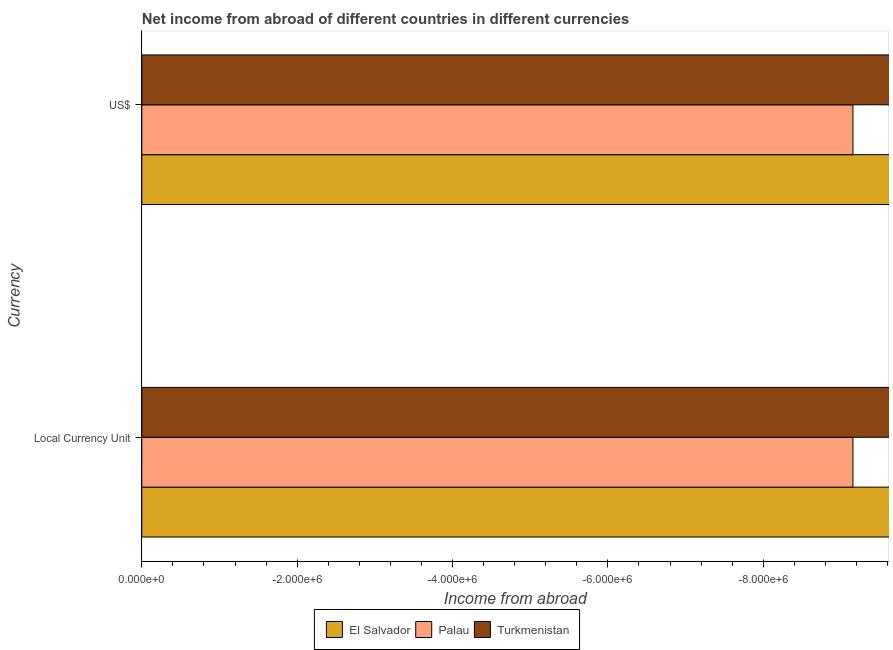Are the number of bars on each tick of the Y-axis equal?
Give a very brief answer. Yes. How many bars are there on the 2nd tick from the top?
Your answer should be compact. 0. How many bars are there on the 1st tick from the bottom?
Ensure brevity in your answer.  0. What is the label of the 1st group of bars from the top?
Ensure brevity in your answer.  US$. What is the income from abroad in us$ in Palau?
Your answer should be very brief. 0. What is the total income from abroad in us$ in the graph?
Make the answer very short. 0. In how many countries, is the income from abroad in us$ greater than -4400000 units?
Make the answer very short. 0. Are all the bars in the graph horizontal?
Give a very brief answer. Yes. What is the difference between two consecutive major ticks on the X-axis?
Provide a succinct answer. 2.00e+06. Are the values on the major ticks of X-axis written in scientific E-notation?
Your answer should be very brief. Yes. Does the graph contain any zero values?
Offer a terse response. Yes. Does the graph contain grids?
Provide a succinct answer. No. What is the title of the graph?
Ensure brevity in your answer.  Net income from abroad of different countries in different currencies. What is the label or title of the X-axis?
Your response must be concise. Income from abroad. What is the label or title of the Y-axis?
Provide a succinct answer. Currency. What is the Income from abroad of El Salvador in Local Currency Unit?
Offer a very short reply. 0. What is the Income from abroad of El Salvador in US$?
Keep it short and to the point. 0. What is the total Income from abroad of El Salvador in the graph?
Offer a terse response. 0. What is the average Income from abroad in Turkmenistan per Currency?
Your response must be concise. 0. 